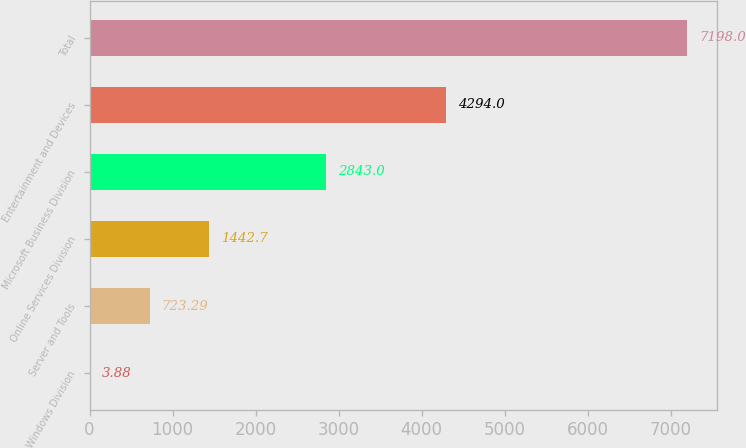Convert chart. <chart><loc_0><loc_0><loc_500><loc_500><bar_chart><fcel>Windows Division<fcel>Server and Tools<fcel>Online Services Division<fcel>Microsoft Business Division<fcel>Entertainment and Devices<fcel>Total<nl><fcel>3.88<fcel>723.29<fcel>1442.7<fcel>2843<fcel>4294<fcel>7198<nl></chart> 